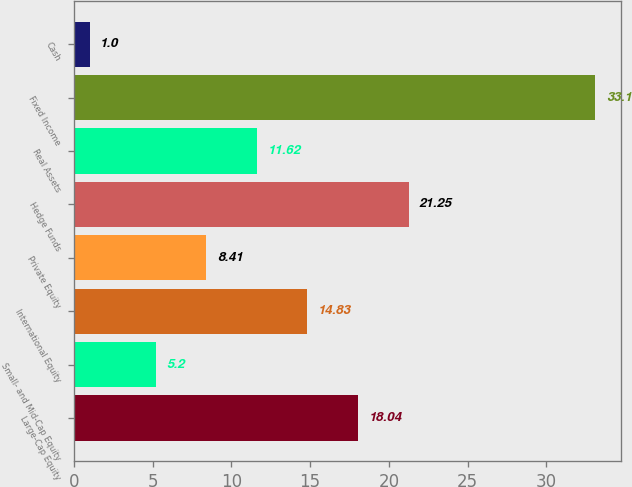Convert chart to OTSL. <chart><loc_0><loc_0><loc_500><loc_500><bar_chart><fcel>Large-Cap Equity<fcel>Small- and Mid-Cap Equity<fcel>International Equity<fcel>Private Equity<fcel>Hedge Funds<fcel>Real Assets<fcel>Fixed Income<fcel>Cash<nl><fcel>18.04<fcel>5.2<fcel>14.83<fcel>8.41<fcel>21.25<fcel>11.62<fcel>33.1<fcel>1<nl></chart> 